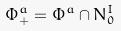Convert formula to latex. <formula><loc_0><loc_0><loc_500><loc_500>\Phi _ { + } ^ { a } = \Phi ^ { a } \cap N _ { 0 } ^ { I }</formula> 